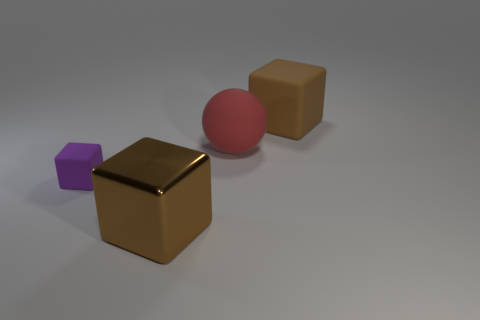There is another cube that is the same color as the large rubber block; what is its material?
Your response must be concise. Metal. Is the metal cube the same color as the big matte cube?
Your answer should be very brief. Yes. There is a big object behind the sphere; does it have the same shape as the big brown shiny thing?
Make the answer very short. Yes. Are there fewer large brown metal cubes that are behind the brown shiny object than large things?
Your response must be concise. Yes. Is there another small red sphere made of the same material as the sphere?
Keep it short and to the point. No. There is another brown thing that is the same size as the brown metallic thing; what material is it?
Give a very brief answer. Rubber. Are there fewer big red objects behind the red rubber object than tiny rubber things on the left side of the brown matte thing?
Provide a succinct answer. Yes. There is a thing that is to the right of the small purple rubber cube and in front of the big sphere; what is its shape?
Make the answer very short. Cube. How many other big matte things have the same shape as the purple rubber thing?
Your answer should be very brief. 1. There is a purple object that is the same material as the red object; what size is it?
Ensure brevity in your answer.  Small. 